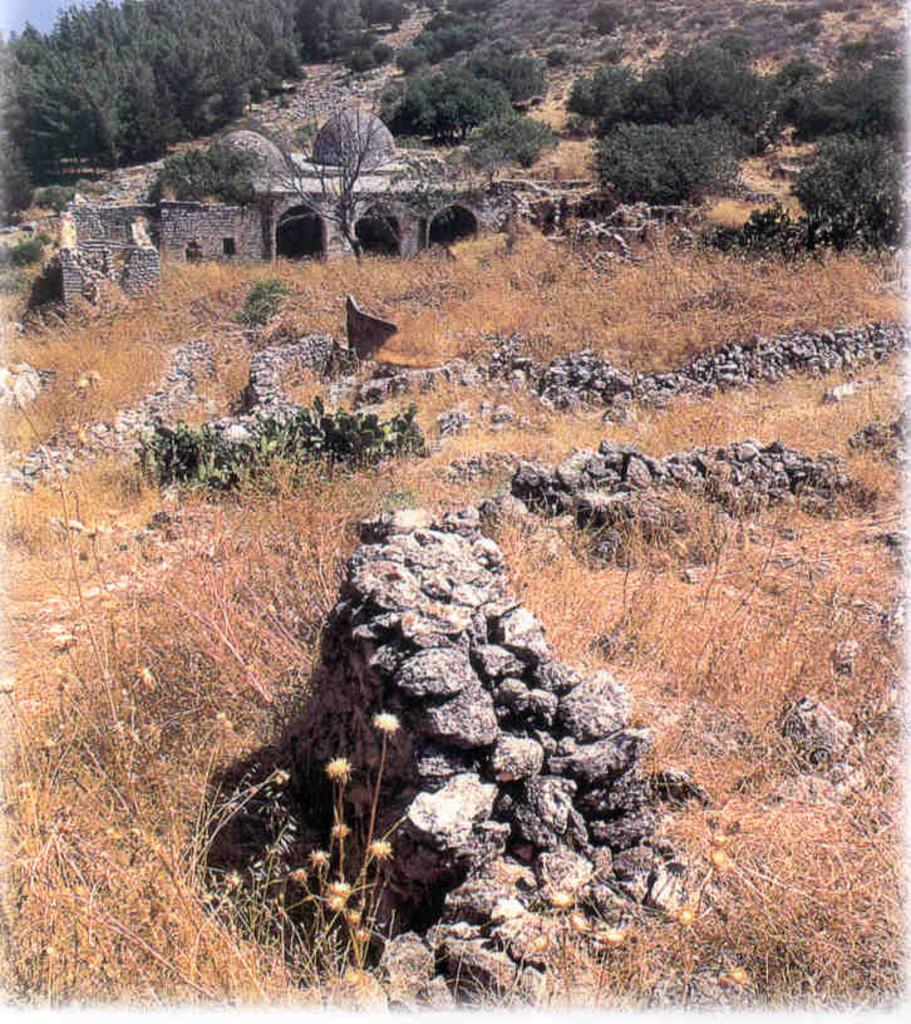What type of environment is depicted in the image? The image is an outside view. What can be seen on the ground in the image? There is grass and rocks on the ground. What is visible in the background of the image? There is a fort and trees in the background. What type of milk is being produced by the cows in the image? There are no cows or milk production visible in the image. How many mines can be seen in the background of the image? There are no mines present in the image; it features a fort and trees in the background. 